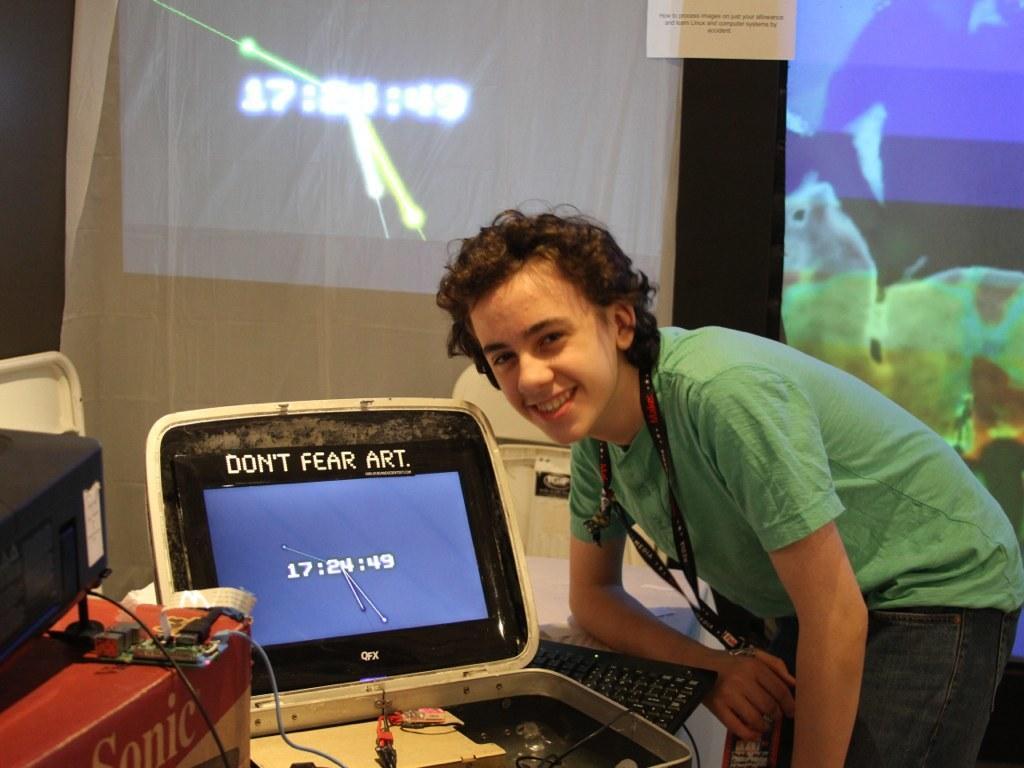Can you describe this image briefly? On the right side of the image we can see a person is bending and wearing a dress and id card. On the left side of the image we can see a screen, keyboard, projector, box and some other objects. In the background of the image we can see the screens, wallpaper. In the paper, we can see the text. 